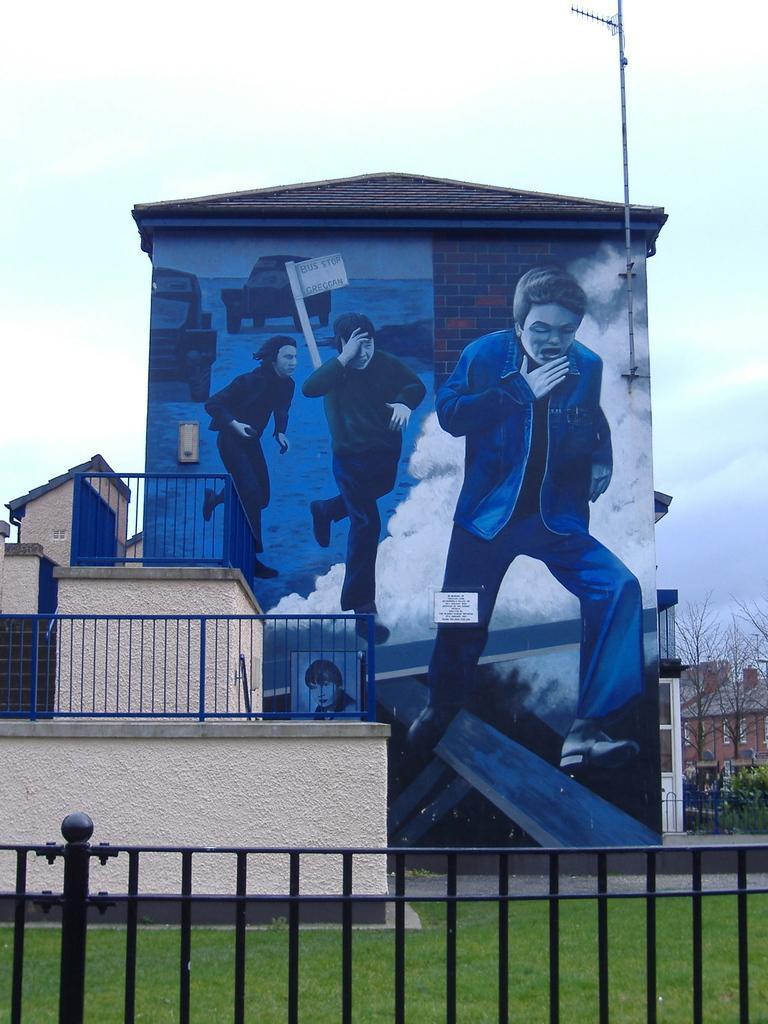In one or two sentences, can you explain what this image depicts? This image consists of a building. At the bottom, there is a railing along with green grass. On the right, there are trees. And we can see a painting on the wall. At the top, there is sky. 